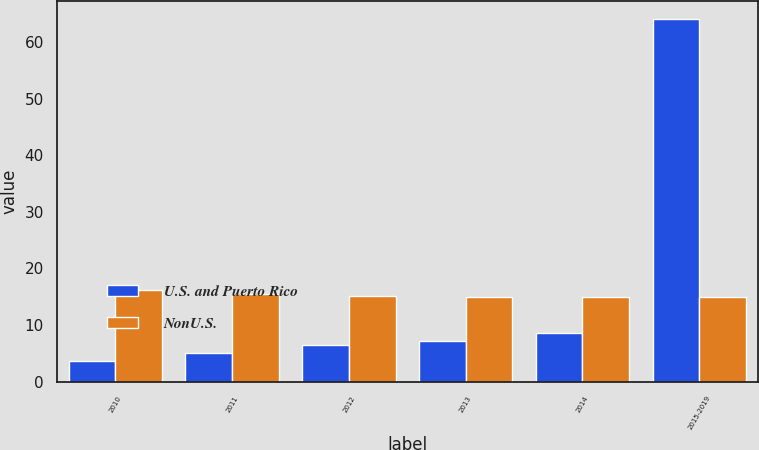<chart> <loc_0><loc_0><loc_500><loc_500><stacked_bar_chart><ecel><fcel>2010<fcel>2011<fcel>2012<fcel>2013<fcel>2014<fcel>2015-2019<nl><fcel>U.S. and Puerto Rico<fcel>3.7<fcel>5.1<fcel>6.5<fcel>7.2<fcel>8.5<fcel>64<nl><fcel>NonU.S.<fcel>16.1<fcel>15.4<fcel>15.2<fcel>14.9<fcel>15<fcel>14.9<nl></chart> 